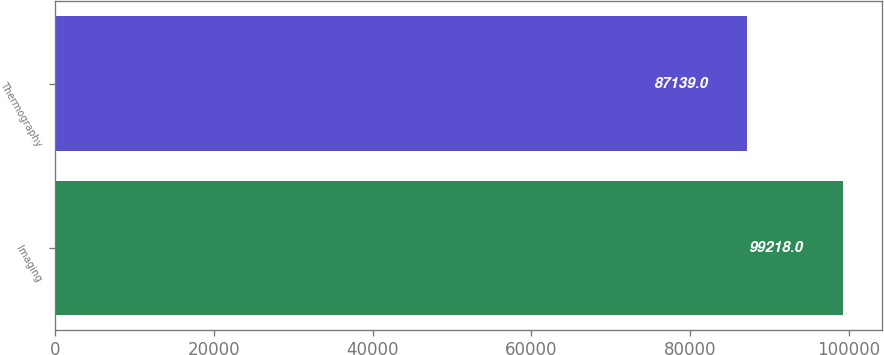Convert chart. <chart><loc_0><loc_0><loc_500><loc_500><bar_chart><fcel>Imaging<fcel>Thermography<nl><fcel>99218<fcel>87139<nl></chart> 